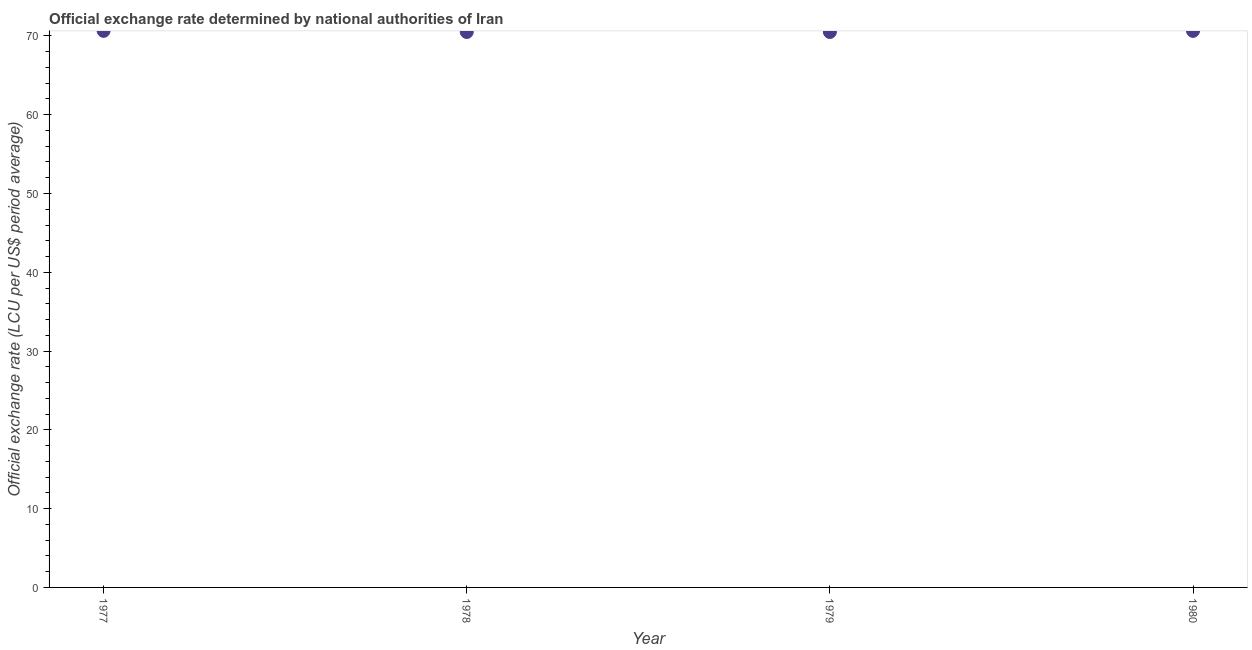What is the official exchange rate in 1979?
Give a very brief answer. 70.5. Across all years, what is the maximum official exchange rate?
Your answer should be very brief. 70.64. Across all years, what is the minimum official exchange rate?
Provide a succinct answer. 70.5. In which year was the official exchange rate minimum?
Offer a very short reply. 1978. What is the sum of the official exchange rate?
Offer a terse response. 282.27. What is the difference between the official exchange rate in 1979 and 1980?
Your response must be concise. -0.14. What is the average official exchange rate per year?
Your response must be concise. 70.57. What is the median official exchange rate?
Your answer should be very brief. 70.57. In how many years, is the official exchange rate greater than 2 ?
Offer a very short reply. 4. Do a majority of the years between 1980 and 1977 (inclusive) have official exchange rate greater than 12 ?
Provide a short and direct response. Yes. What is the ratio of the official exchange rate in 1978 to that in 1979?
Your answer should be very brief. 1. Is the official exchange rate in 1978 less than that in 1980?
Your answer should be compact. Yes. What is the difference between the highest and the second highest official exchange rate?
Your answer should be compact. 0. What is the difference between the highest and the lowest official exchange rate?
Your response must be concise. 0.14. Does the official exchange rate monotonically increase over the years?
Give a very brief answer. No. What is the difference between two consecutive major ticks on the Y-axis?
Provide a succinct answer. 10. Are the values on the major ticks of Y-axis written in scientific E-notation?
Your response must be concise. No. Does the graph contain any zero values?
Provide a short and direct response. No. What is the title of the graph?
Provide a succinct answer. Official exchange rate determined by national authorities of Iran. What is the label or title of the Y-axis?
Offer a very short reply. Official exchange rate (LCU per US$ period average). What is the Official exchange rate (LCU per US$ period average) in 1977?
Make the answer very short. 70.64. What is the Official exchange rate (LCU per US$ period average) in 1978?
Offer a very short reply. 70.5. What is the Official exchange rate (LCU per US$ period average) in 1979?
Offer a terse response. 70.5. What is the Official exchange rate (LCU per US$ period average) in 1980?
Ensure brevity in your answer.  70.64. What is the difference between the Official exchange rate (LCU per US$ period average) in 1977 and 1978?
Offer a very short reply. 0.14. What is the difference between the Official exchange rate (LCU per US$ period average) in 1977 and 1979?
Provide a succinct answer. 0.14. What is the difference between the Official exchange rate (LCU per US$ period average) in 1977 and 1980?
Your answer should be compact. 0. What is the difference between the Official exchange rate (LCU per US$ period average) in 1978 and 1979?
Offer a very short reply. 0. What is the difference between the Official exchange rate (LCU per US$ period average) in 1978 and 1980?
Ensure brevity in your answer.  -0.14. What is the difference between the Official exchange rate (LCU per US$ period average) in 1979 and 1980?
Give a very brief answer. -0.14. What is the ratio of the Official exchange rate (LCU per US$ period average) in 1977 to that in 1978?
Ensure brevity in your answer.  1. What is the ratio of the Official exchange rate (LCU per US$ period average) in 1977 to that in 1979?
Your response must be concise. 1. What is the ratio of the Official exchange rate (LCU per US$ period average) in 1978 to that in 1980?
Keep it short and to the point. 1. 